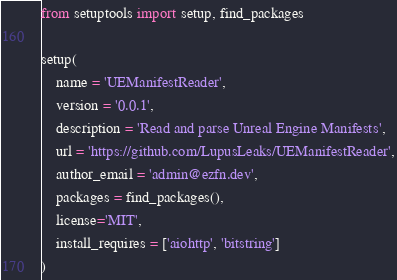<code> <loc_0><loc_0><loc_500><loc_500><_Python_>from setuptools import setup, find_packages

setup(
    name = 'UEManifestReader',
    version = '0.0.1',
    description = 'Read and parse Unreal Engine Manifests',
    url = 'https://github.com/LupusLeaks/UEManifestReader',
    author_email = 'admin@ezfn.dev',
    packages = find_packages(),
    license='MIT',
    install_requires = ['aiohttp', 'bitstring']
)</code> 